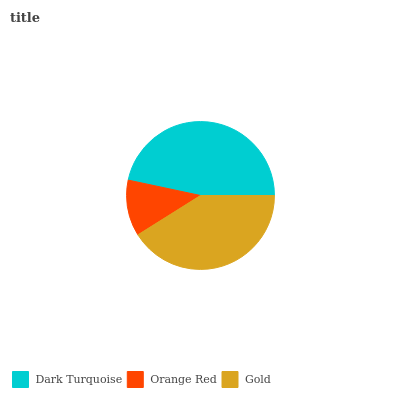Is Orange Red the minimum?
Answer yes or no. Yes. Is Dark Turquoise the maximum?
Answer yes or no. Yes. Is Gold the minimum?
Answer yes or no. No. Is Gold the maximum?
Answer yes or no. No. Is Gold greater than Orange Red?
Answer yes or no. Yes. Is Orange Red less than Gold?
Answer yes or no. Yes. Is Orange Red greater than Gold?
Answer yes or no. No. Is Gold less than Orange Red?
Answer yes or no. No. Is Gold the high median?
Answer yes or no. Yes. Is Gold the low median?
Answer yes or no. Yes. Is Orange Red the high median?
Answer yes or no. No. Is Orange Red the low median?
Answer yes or no. No. 